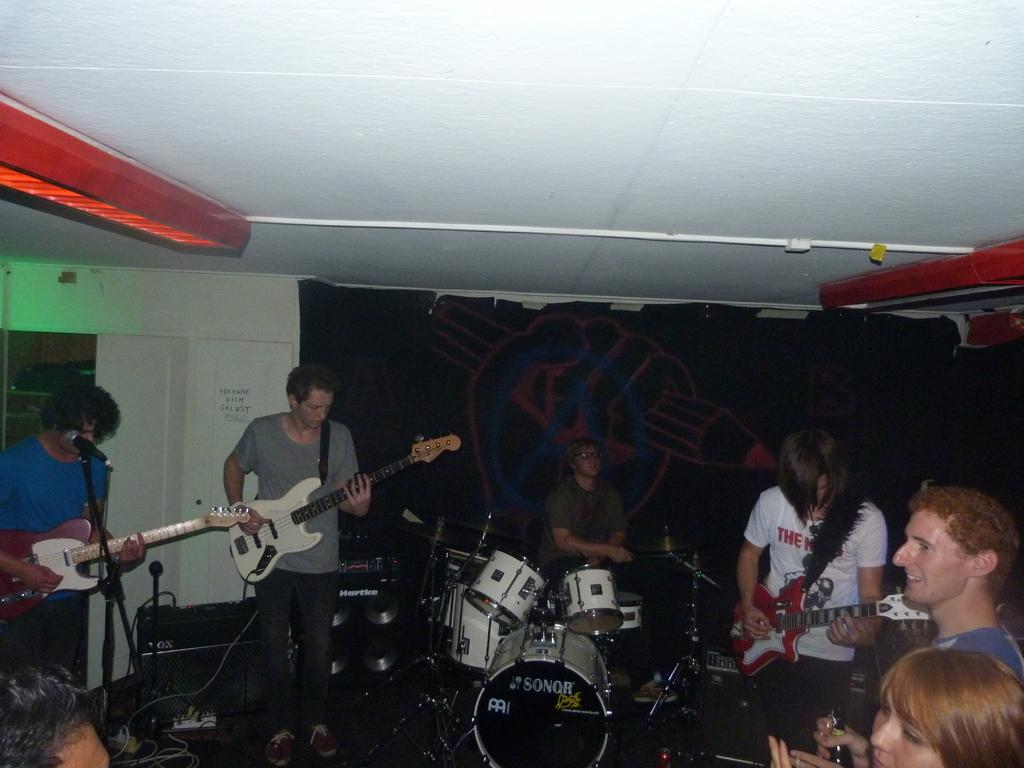What type of group is present in the room? There is a music band in the room. How many members of the band are playing guitars? Three members of the band are playing guitars. What instrument is the fourth member of the band playing? One member of the band is playing drums. What can be seen on the wall behind the band? There is a painted wall in the background of the room. What type of finger can be seen holding a twig in the image? There is no finger or twig present in the image; it features a music band playing instruments. 